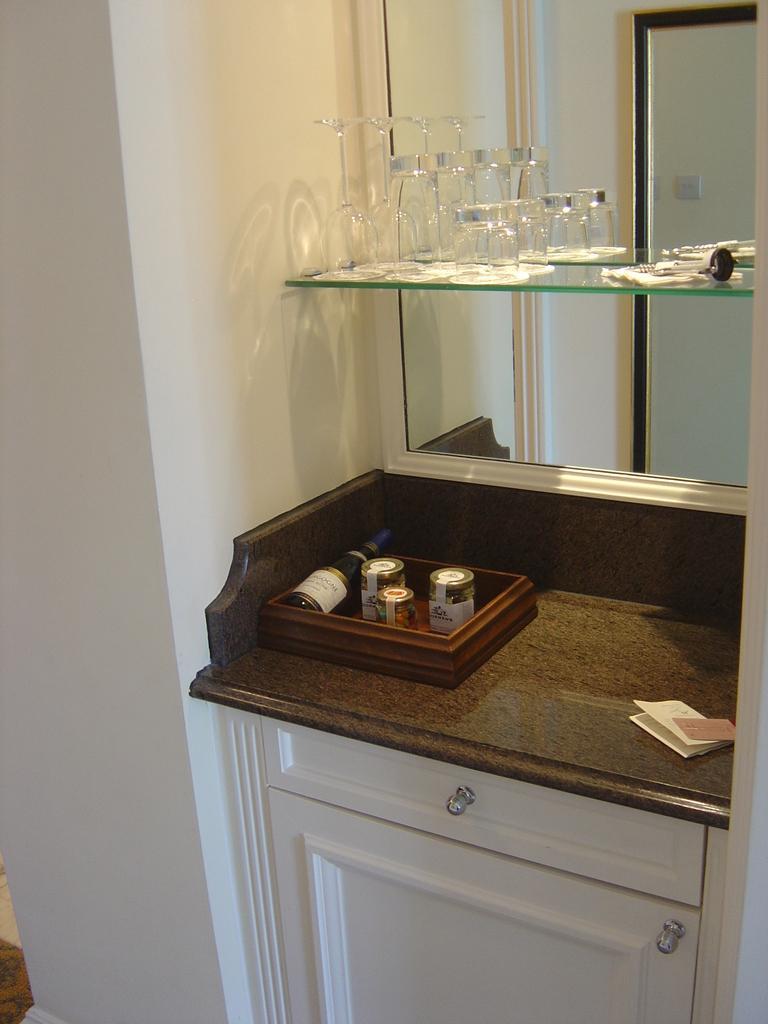How would you summarize this image in a sentence or two? In the image we can see a wall, on the wall we can see a table. On the table we can see some papers, bottles and we can see a mirror, on the mirror we can see some glasses. 